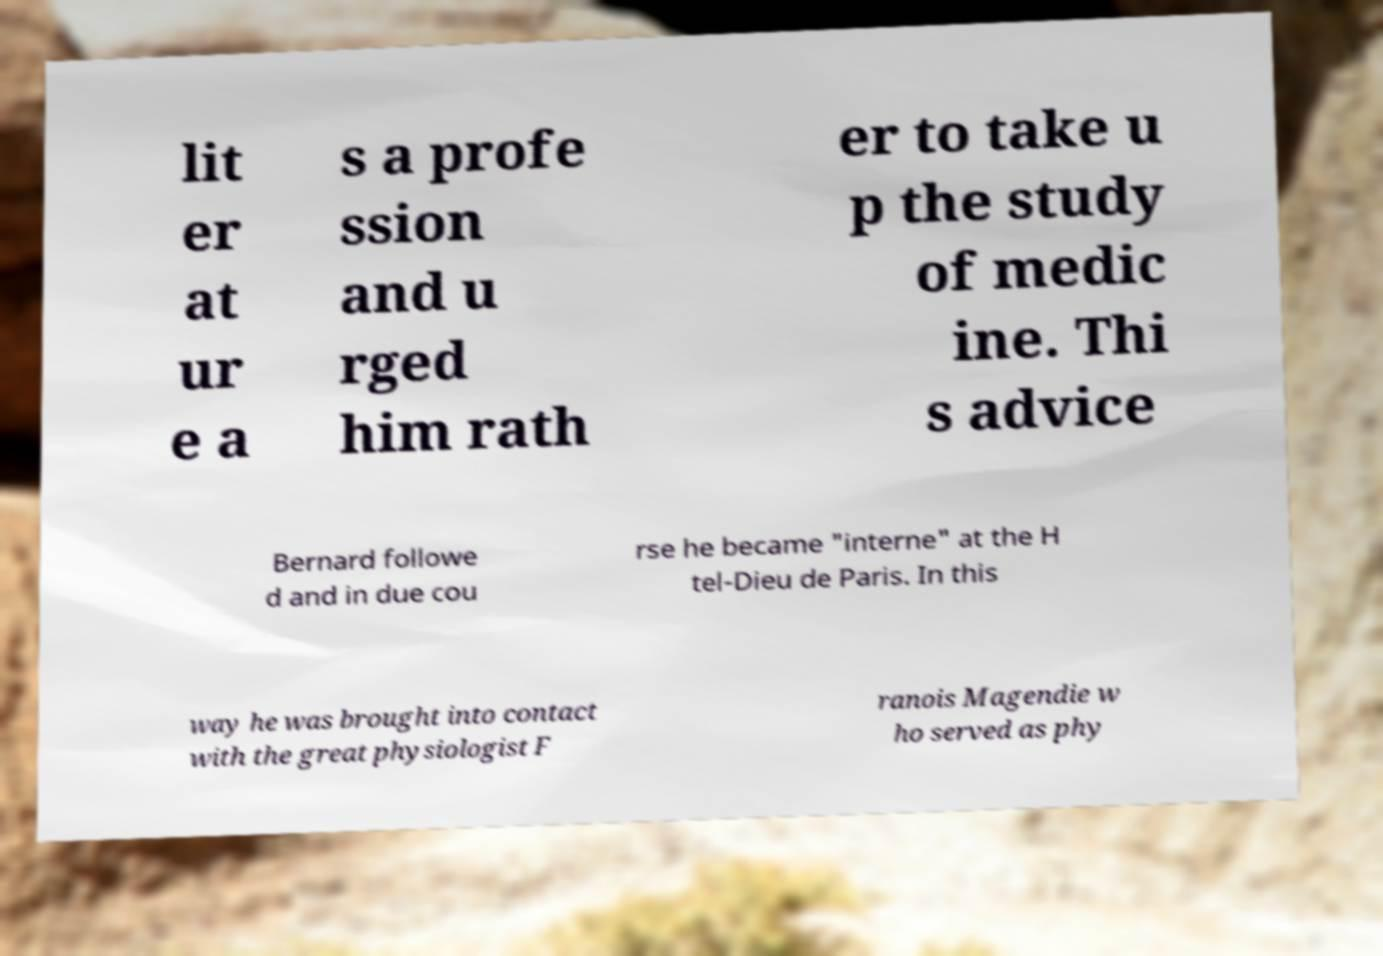Please read and relay the text visible in this image. What does it say? lit er at ur e a s a profe ssion and u rged him rath er to take u p the study of medic ine. Thi s advice Bernard followe d and in due cou rse he became "interne" at the H tel-Dieu de Paris. In this way he was brought into contact with the great physiologist F ranois Magendie w ho served as phy 